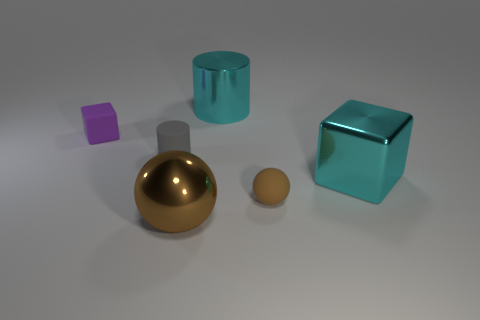There is a big object that is in front of the large cyan object that is to the right of the big thing that is behind the gray rubber cylinder; what is its color?
Your answer should be very brief. Brown. Is the number of purple rubber things that are to the left of the small purple matte block less than the number of small things that are on the left side of the tiny brown sphere?
Offer a very short reply. Yes. Is the shape of the brown matte object the same as the large brown thing?
Offer a very short reply. Yes. How many brown metallic spheres are the same size as the cyan cylinder?
Offer a very short reply. 1. Are there fewer big cyan metallic cubes left of the purple block than shiny cubes?
Your answer should be very brief. Yes. What size is the cylinder that is right of the metallic object that is in front of the brown rubber object?
Keep it short and to the point. Large. What number of objects are big metal blocks or cyan metallic things?
Give a very brief answer. 2. Is there a tiny object that has the same color as the large sphere?
Ensure brevity in your answer.  Yes. Is the number of big brown metal objects less than the number of cyan rubber cubes?
Provide a short and direct response. No. What number of things are large cyan objects or spheres that are to the left of the large cylinder?
Give a very brief answer. 3. 